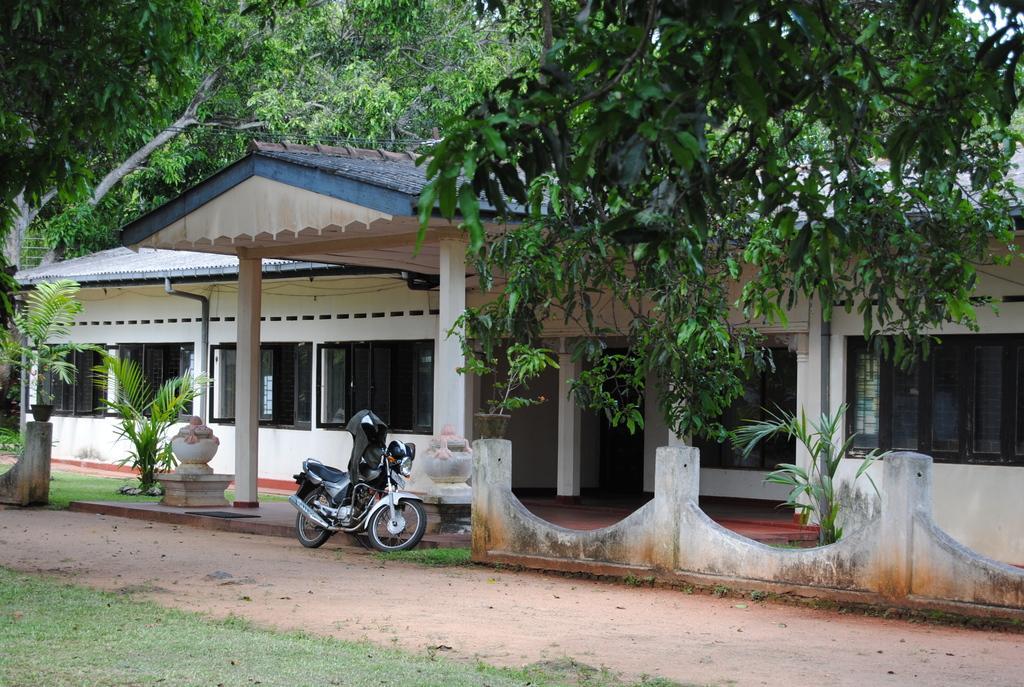Can you describe this image briefly? In this image we can see a house with windows and pillars. In front of the house there is a bike. Also there is a wall. And there are plants. And there are many trees. Also there are some decorative items on the pedestals. 